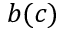Convert formula to latex. <formula><loc_0><loc_0><loc_500><loc_500>b ( c )</formula> 